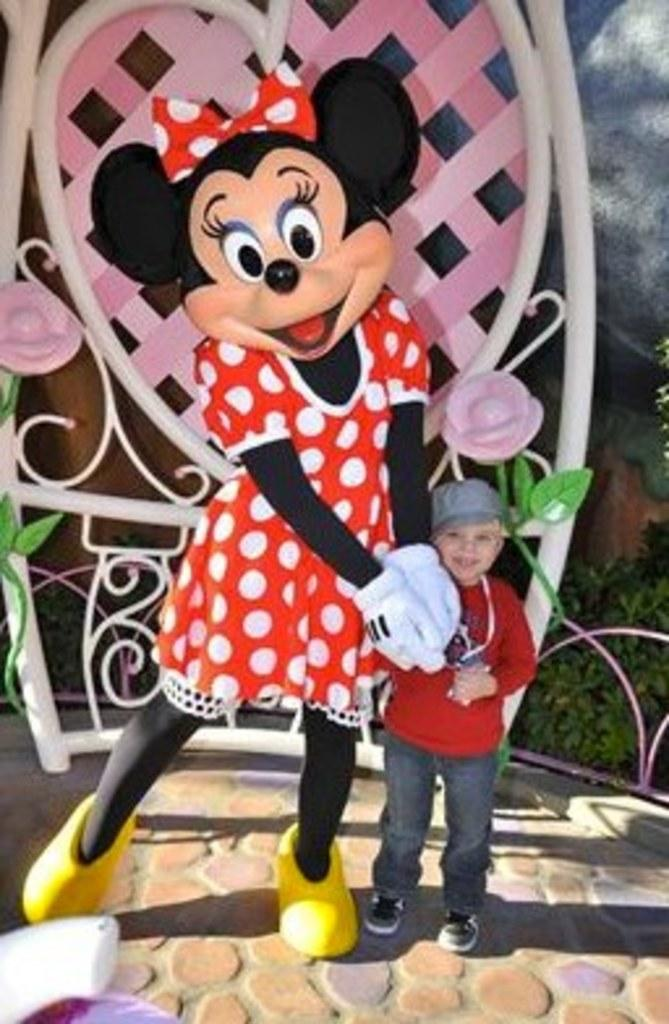Who is present in the image? There is a boy in the image. What is the boy standing beside? The boy is standing beside a Mickey Mouse mannequin. What can be seen in the background of the image? There is a colorful fence visible in the image. What type of vegetation is on the right side of the image? Some plants are visible on the right side of the image. What reason does the boy give for standing beside the Mickey Mouse mannequin in the image? The image does not provide any information about the boy's reason for standing beside the Mickey Mouse mannequin, so we cannot determine his reason from the image. 